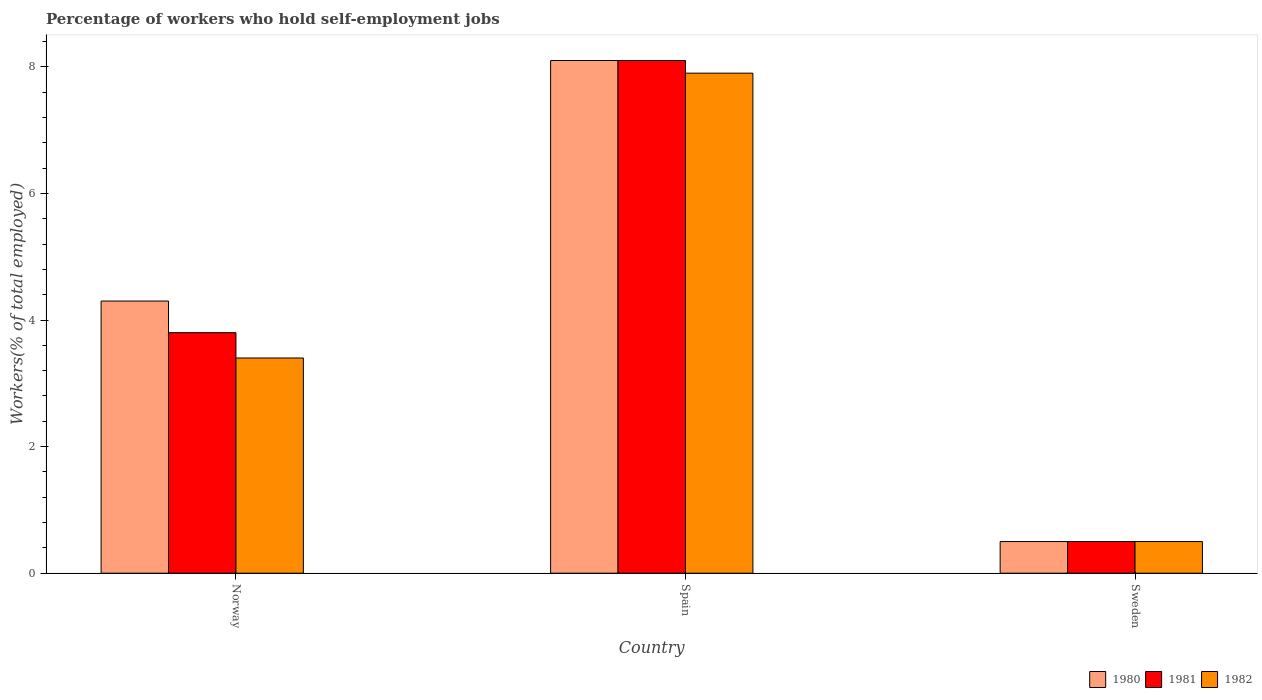How many different coloured bars are there?
Provide a succinct answer. 3. How many groups of bars are there?
Offer a terse response. 3. How many bars are there on the 2nd tick from the right?
Ensure brevity in your answer.  3. What is the percentage of self-employed workers in 1980 in Spain?
Offer a terse response. 8.1. Across all countries, what is the maximum percentage of self-employed workers in 1980?
Your answer should be very brief. 8.1. Across all countries, what is the minimum percentage of self-employed workers in 1981?
Offer a very short reply. 0.5. What is the total percentage of self-employed workers in 1981 in the graph?
Your answer should be compact. 12.4. What is the difference between the percentage of self-employed workers in 1982 in Spain and that in Sweden?
Make the answer very short. 7.4. What is the difference between the percentage of self-employed workers in 1982 in Spain and the percentage of self-employed workers in 1981 in Sweden?
Provide a succinct answer. 7.4. What is the average percentage of self-employed workers in 1982 per country?
Your answer should be compact. 3.93. What is the difference between the percentage of self-employed workers of/in 1980 and percentage of self-employed workers of/in 1981 in Spain?
Offer a terse response. 0. In how many countries, is the percentage of self-employed workers in 1981 greater than 7.6 %?
Make the answer very short. 1. What is the ratio of the percentage of self-employed workers in 1980 in Spain to that in Sweden?
Offer a very short reply. 16.2. Is the percentage of self-employed workers in 1982 in Norway less than that in Spain?
Your answer should be very brief. Yes. What is the difference between the highest and the second highest percentage of self-employed workers in 1982?
Give a very brief answer. -2.9. What is the difference between the highest and the lowest percentage of self-employed workers in 1980?
Give a very brief answer. 7.6. What does the 2nd bar from the left in Spain represents?
Ensure brevity in your answer.  1981. How many countries are there in the graph?
Provide a succinct answer. 3. How are the legend labels stacked?
Your answer should be compact. Horizontal. What is the title of the graph?
Your response must be concise. Percentage of workers who hold self-employment jobs. Does "1981" appear as one of the legend labels in the graph?
Make the answer very short. Yes. What is the label or title of the X-axis?
Give a very brief answer. Country. What is the label or title of the Y-axis?
Offer a very short reply. Workers(% of total employed). What is the Workers(% of total employed) of 1980 in Norway?
Ensure brevity in your answer.  4.3. What is the Workers(% of total employed) in 1981 in Norway?
Your answer should be compact. 3.8. What is the Workers(% of total employed) in 1982 in Norway?
Keep it short and to the point. 3.4. What is the Workers(% of total employed) in 1980 in Spain?
Provide a succinct answer. 8.1. What is the Workers(% of total employed) in 1981 in Spain?
Ensure brevity in your answer.  8.1. What is the Workers(% of total employed) in 1982 in Spain?
Your answer should be very brief. 7.9. What is the Workers(% of total employed) of 1980 in Sweden?
Offer a very short reply. 0.5. What is the Workers(% of total employed) in 1982 in Sweden?
Give a very brief answer. 0.5. Across all countries, what is the maximum Workers(% of total employed) in 1980?
Offer a very short reply. 8.1. Across all countries, what is the maximum Workers(% of total employed) in 1981?
Offer a terse response. 8.1. Across all countries, what is the maximum Workers(% of total employed) of 1982?
Give a very brief answer. 7.9. Across all countries, what is the minimum Workers(% of total employed) in 1980?
Your response must be concise. 0.5. Across all countries, what is the minimum Workers(% of total employed) of 1981?
Give a very brief answer. 0.5. Across all countries, what is the minimum Workers(% of total employed) of 1982?
Make the answer very short. 0.5. What is the total Workers(% of total employed) of 1980 in the graph?
Your answer should be very brief. 12.9. What is the total Workers(% of total employed) in 1981 in the graph?
Provide a succinct answer. 12.4. What is the difference between the Workers(% of total employed) of 1980 in Norway and that in Spain?
Offer a very short reply. -3.8. What is the difference between the Workers(% of total employed) in 1981 in Norway and that in Spain?
Provide a short and direct response. -4.3. What is the difference between the Workers(% of total employed) of 1982 in Norway and that in Spain?
Your answer should be compact. -4.5. What is the difference between the Workers(% of total employed) of 1981 in Norway and that in Sweden?
Keep it short and to the point. 3.3. What is the difference between the Workers(% of total employed) in 1980 in Spain and that in Sweden?
Your response must be concise. 7.6. What is the difference between the Workers(% of total employed) of 1980 in Norway and the Workers(% of total employed) of 1982 in Spain?
Provide a succinct answer. -3.6. What is the difference between the Workers(% of total employed) of 1981 in Norway and the Workers(% of total employed) of 1982 in Spain?
Make the answer very short. -4.1. What is the difference between the Workers(% of total employed) of 1980 in Norway and the Workers(% of total employed) of 1981 in Sweden?
Your response must be concise. 3.8. What is the difference between the Workers(% of total employed) of 1980 in Norway and the Workers(% of total employed) of 1982 in Sweden?
Ensure brevity in your answer.  3.8. What is the difference between the Workers(% of total employed) in 1981 in Norway and the Workers(% of total employed) in 1982 in Sweden?
Keep it short and to the point. 3.3. What is the difference between the Workers(% of total employed) of 1980 in Spain and the Workers(% of total employed) of 1981 in Sweden?
Give a very brief answer. 7.6. What is the difference between the Workers(% of total employed) of 1981 in Spain and the Workers(% of total employed) of 1982 in Sweden?
Ensure brevity in your answer.  7.6. What is the average Workers(% of total employed) in 1980 per country?
Your response must be concise. 4.3. What is the average Workers(% of total employed) in 1981 per country?
Give a very brief answer. 4.13. What is the average Workers(% of total employed) of 1982 per country?
Offer a very short reply. 3.93. What is the difference between the Workers(% of total employed) of 1980 and Workers(% of total employed) of 1982 in Norway?
Provide a short and direct response. 0.9. What is the difference between the Workers(% of total employed) of 1981 and Workers(% of total employed) of 1982 in Norway?
Your answer should be very brief. 0.4. What is the difference between the Workers(% of total employed) in 1980 and Workers(% of total employed) in 1981 in Spain?
Ensure brevity in your answer.  0. What is the difference between the Workers(% of total employed) of 1980 and Workers(% of total employed) of 1982 in Spain?
Provide a short and direct response. 0.2. What is the difference between the Workers(% of total employed) in 1981 and Workers(% of total employed) in 1982 in Spain?
Give a very brief answer. 0.2. What is the difference between the Workers(% of total employed) in 1980 and Workers(% of total employed) in 1981 in Sweden?
Provide a short and direct response. 0. What is the difference between the Workers(% of total employed) of 1980 and Workers(% of total employed) of 1982 in Sweden?
Your answer should be compact. 0. What is the ratio of the Workers(% of total employed) of 1980 in Norway to that in Spain?
Keep it short and to the point. 0.53. What is the ratio of the Workers(% of total employed) of 1981 in Norway to that in Spain?
Ensure brevity in your answer.  0.47. What is the ratio of the Workers(% of total employed) in 1982 in Norway to that in Spain?
Ensure brevity in your answer.  0.43. What is the ratio of the Workers(% of total employed) in 1980 in Norway to that in Sweden?
Make the answer very short. 8.6. What is the ratio of the Workers(% of total employed) of 1981 in Norway to that in Sweden?
Make the answer very short. 7.6. What is the difference between the highest and the lowest Workers(% of total employed) of 1981?
Provide a short and direct response. 7.6. 